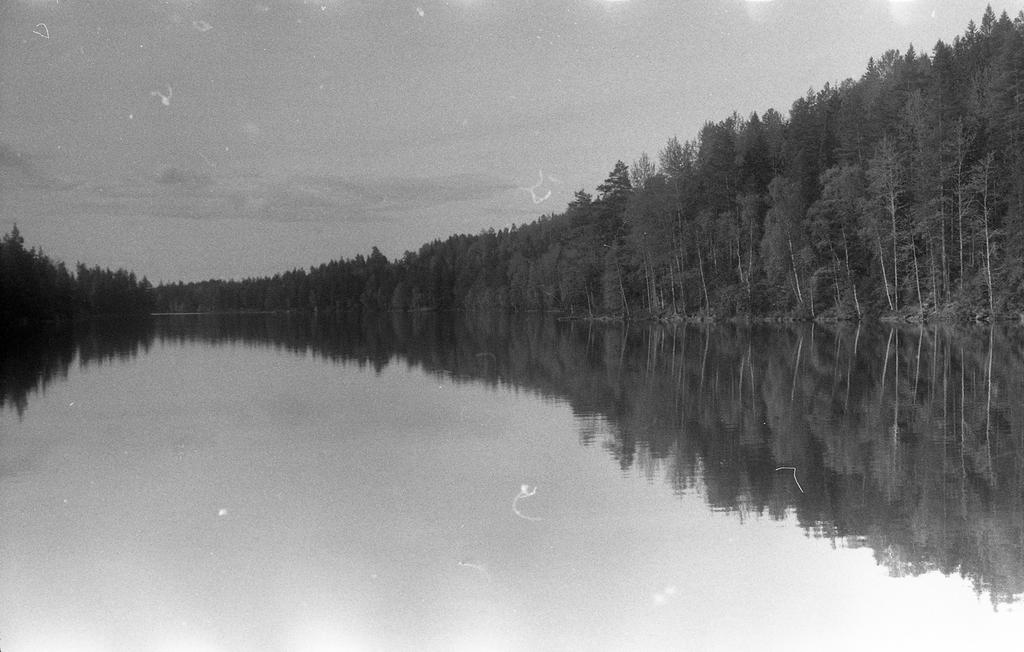What is visible in the image? Water, trees, and the sky are visible in the image. Can you describe the natural elements in the image? There are trees and water visible in the image, which suggests a natural setting. What can be seen in the background of the image? The sky is visible in the background of the image. Can you tell me how many women are visible in the image? There are no women present in the image; it features water, trees, and the sky. What type of flesh can be seen in the image? There is no flesh visible in the image; it features water, trees, and the sky. 